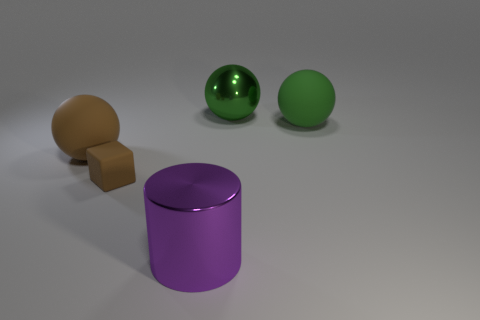Is there any other thing that has the same size as the brown cube?
Give a very brief answer. No. Are there fewer green metal cylinders than big brown matte spheres?
Your answer should be compact. Yes. There is a large shiny object that is in front of the big rubber sphere to the right of the matte ball on the left side of the rubber cube; what is its shape?
Provide a succinct answer. Cylinder. The matte object that is the same color as the matte block is what shape?
Offer a terse response. Sphere. Are any large brown metallic cylinders visible?
Provide a short and direct response. No. Does the matte block have the same size as the brown object behind the block?
Ensure brevity in your answer.  No. Is there a matte thing that is behind the object that is on the left side of the tiny matte block?
Make the answer very short. Yes. There is a sphere that is in front of the big green metallic ball and on the right side of the brown cube; what is its material?
Offer a terse response. Rubber. There is a big rubber object right of the green metal ball behind the matte sphere that is on the right side of the purple metal thing; what is its color?
Your answer should be very brief. Green. What color is the metallic cylinder that is the same size as the green rubber ball?
Give a very brief answer. Purple. 